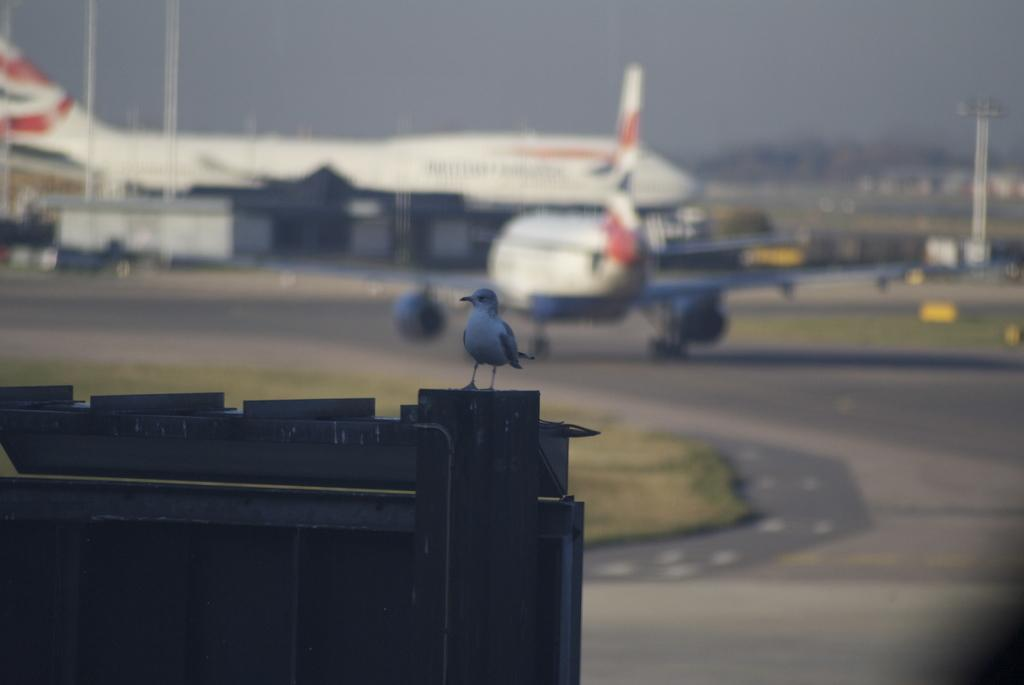What is located at the bottom of the image? There is an object at the bottom of the image. What can be seen in the middle of the image? There are airplanes in the middle of the image. What is on the right side of the image? There is a pole on the right side of the image. How many passengers are visible in the image? There is no reference to passengers in the image, as it only features an object, airplanes, and a pole. What type of work is being done by the army in the image? There is no mention of the army or any work being done in the image. 